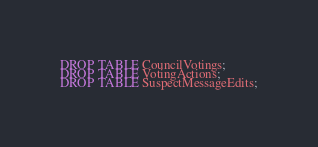<code> <loc_0><loc_0><loc_500><loc_500><_SQL_>DROP TABLE CouncilVotings;
DROP TABLE VotingActions;
DROP TABLE SuspectMessageEdits;
</code> 